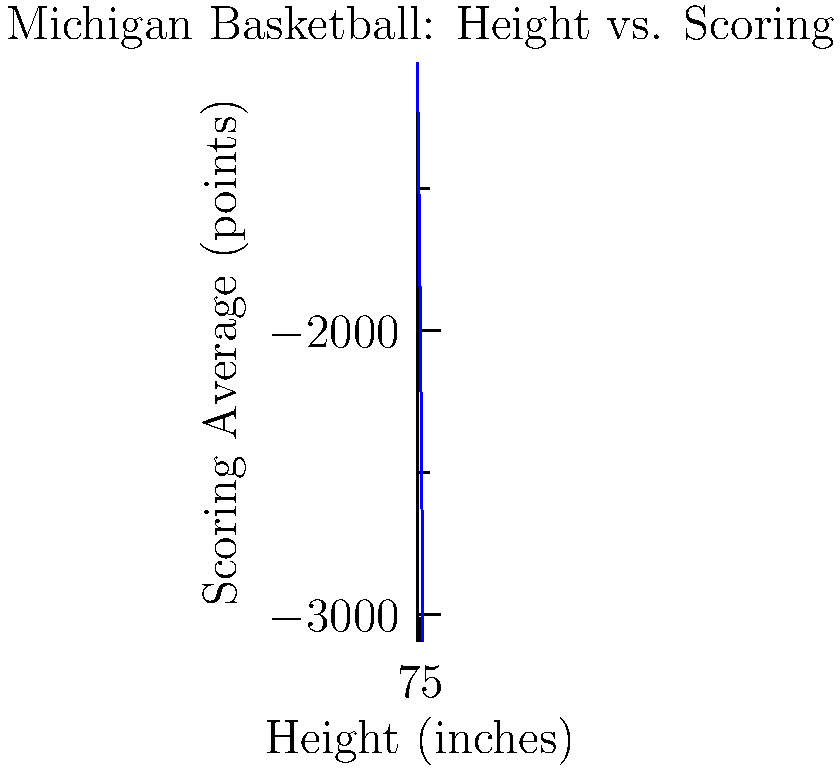Based on the polynomial graph showing the relationship between player height and scoring average in Michigan basketball, at approximately what height does a player reach their peak scoring average? To find the height at which a player reaches their peak scoring average, we need to analyze the graph:

1. The graph represents a cubic function, which has one local maximum and one local minimum.

2. We're interested in the local maximum, which represents the peak scoring average.

3. Visually, we can see that the curve reaches its highest point between 75 and 80 inches on the x-axis.

4. To be more precise, we can estimate that the peak occurs around 77-78 inches.

5. This makes sense in the context of basketball, as players around 6'5" to 6'6" (77-78 inches) often combine height advantage with agility, allowing them to score effectively.

6. Players shorter than this may struggle against taller defenders, while much taller players (like centers) often focus more on rebounding and defense than scoring.

Therefore, based on this graph, Michigan basketball players reach their peak scoring average at approximately 77-78 inches in height.
Answer: 77-78 inches 